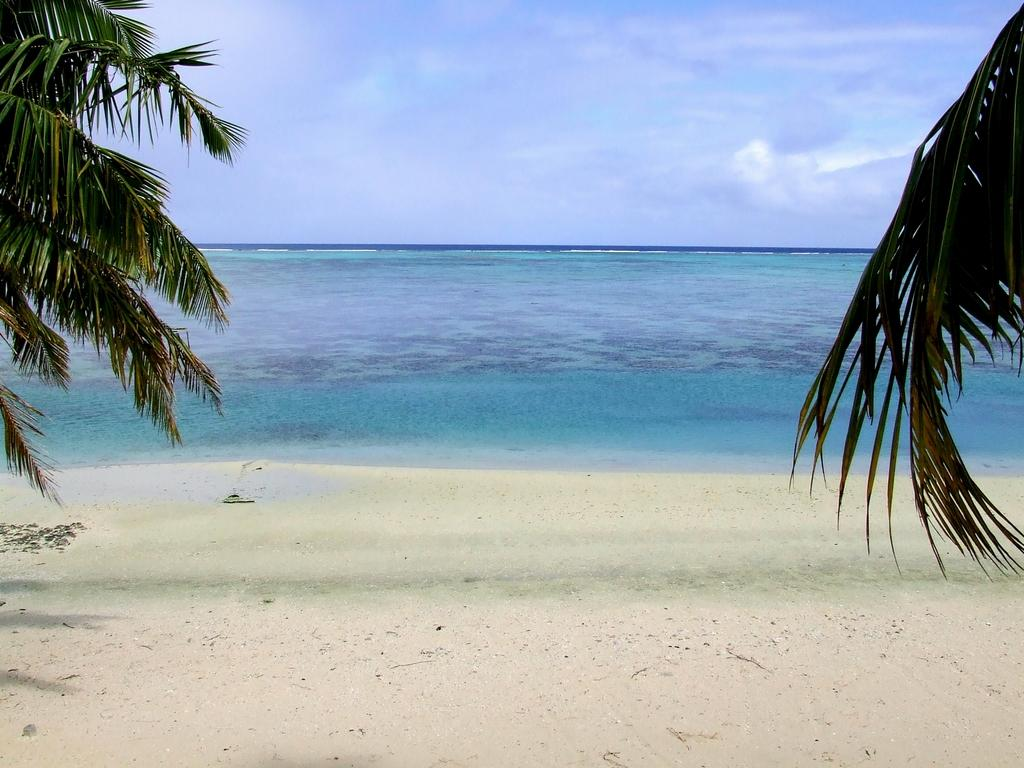What type of vegetation can be seen in the image? There are trees in the image. What type of terrain is visible in the image? There is sand in the image. What natural element is present in the image? There is water in the image. What can be seen in the background of the image? The sky is visible in the background of the image. What is the condition of the sky in the image? There are clouds in the sky. Where is the coal mine located in the image? There is no coal mine present in the image. What wish is granted by the water in the image? There is no wish-granting power associated with the water in the image. 